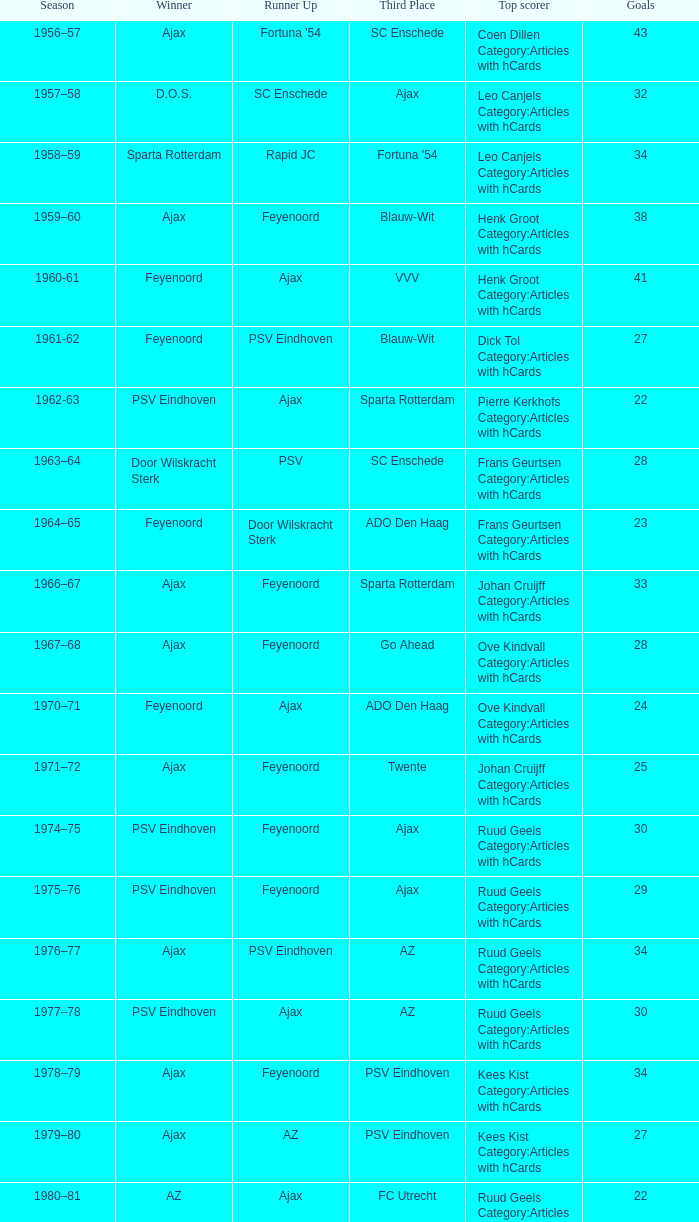When twente came in third place and ajax was the winner what are the seasons? 1971–72, 1989-90. 